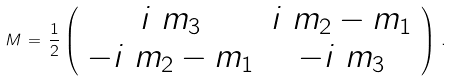<formula> <loc_0><loc_0><loc_500><loc_500>M \, = \, \frac { 1 } { 2 } \left ( \begin{array} { c c } i \ m _ { 3 } & i \ m _ { 2 } - m _ { 1 } \\ - i \ m _ { 2 } - m _ { 1 } & - i \ m _ { 3 } \end{array} \right ) \, .</formula> 